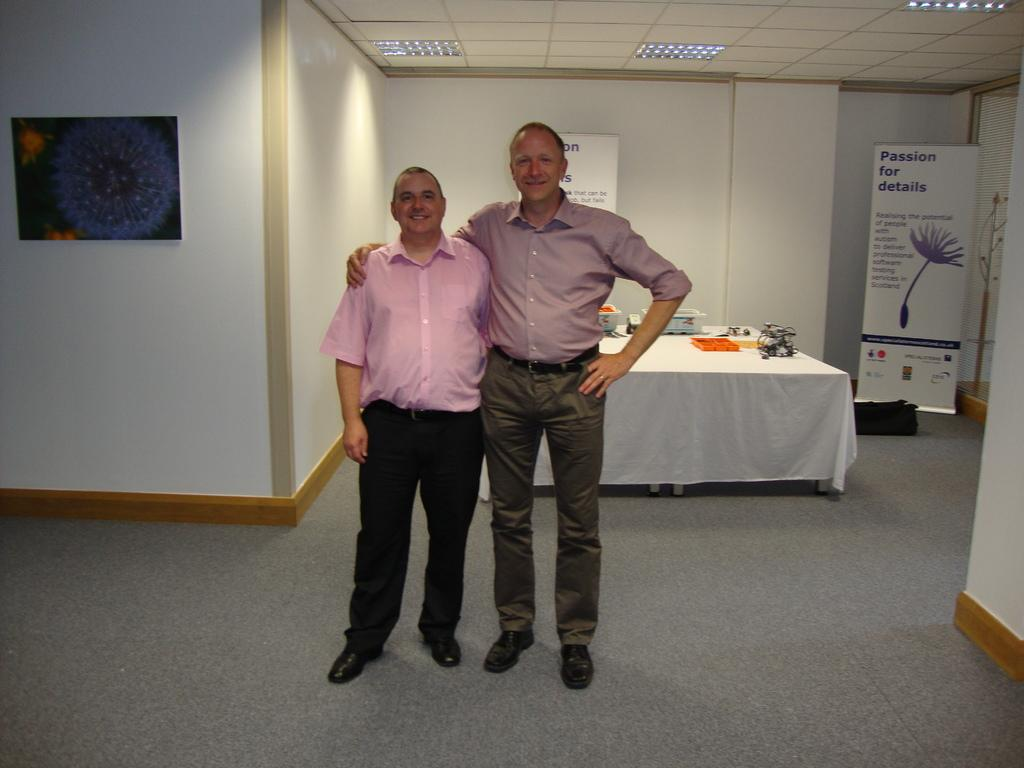How many people are in the image? There are two people in the image. What are the people doing in the image? The people are on the floor and smiling. What can be seen in the background of the image? There is a wall, boards, a table, a roof, lights, and some objects in the background of the image. What type of toothpaste is the person using in the image? There is no toothpaste present in the image; the people are on the floor and smiling. What is the duration of the recess in the image? There is no recess depicted in the image; it features two people on the floor and smiling, along with various elements in the background. 